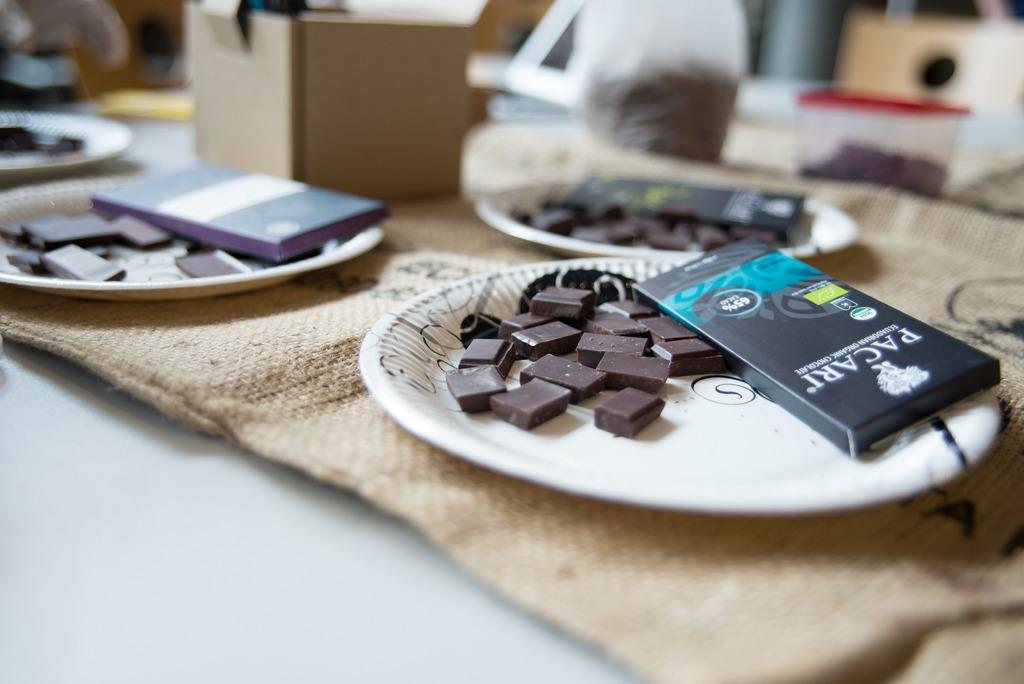<image>
Write a terse but informative summary of the picture. A paper plate with squares of Pacari chocolate on it. 